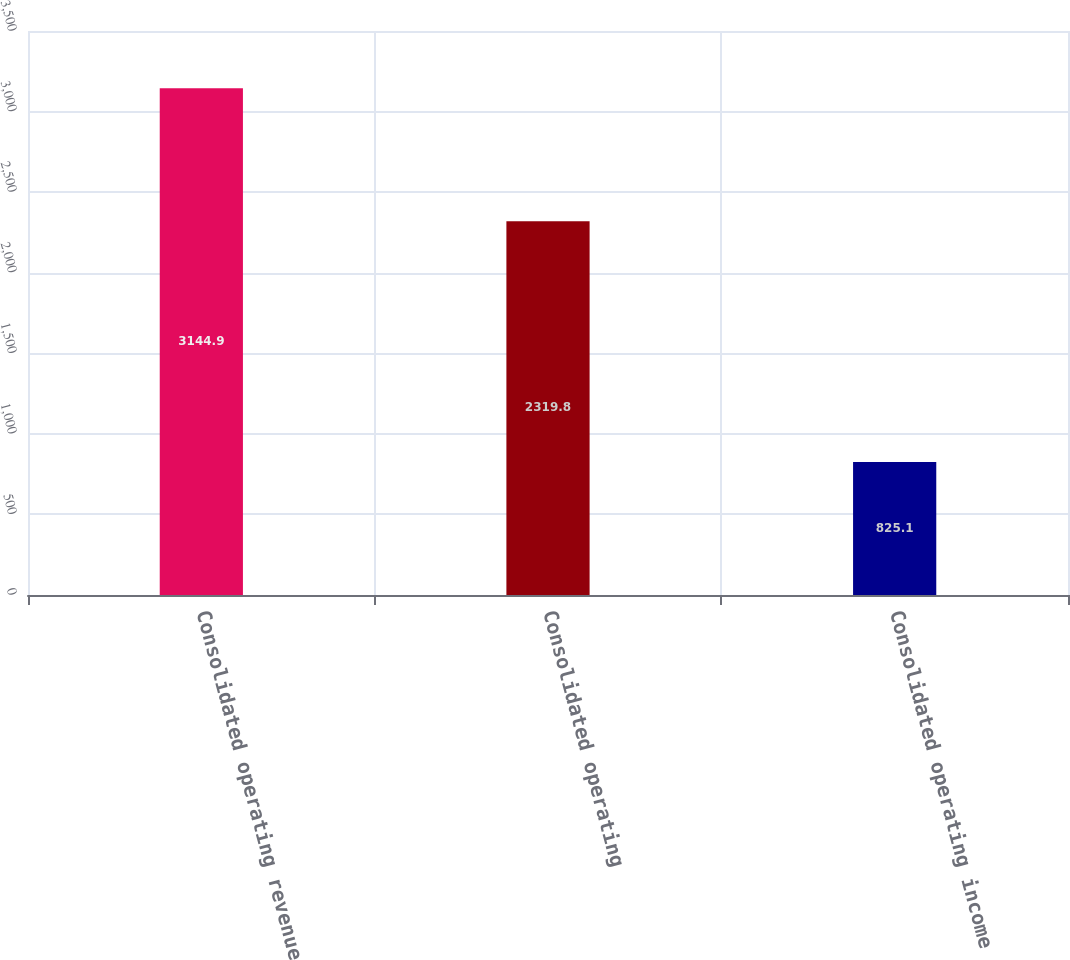Convert chart to OTSL. <chart><loc_0><loc_0><loc_500><loc_500><bar_chart><fcel>Consolidated operating revenue<fcel>Consolidated operating<fcel>Consolidated operating income<nl><fcel>3144.9<fcel>2319.8<fcel>825.1<nl></chart> 